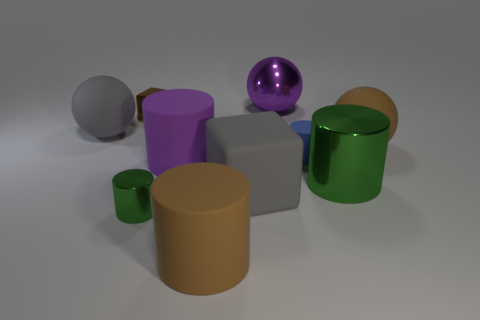Subtract 1 cylinders. How many cylinders are left? 4 Subtract all brown cylinders. How many cylinders are left? 4 Subtract all blue matte cylinders. How many cylinders are left? 4 Subtract all purple cylinders. Subtract all yellow balls. How many cylinders are left? 4 Subtract all cubes. How many objects are left? 8 Add 8 big purple matte cylinders. How many big purple matte cylinders are left? 9 Add 5 large green metallic cylinders. How many large green metallic cylinders exist? 6 Subtract 0 purple cubes. How many objects are left? 10 Subtract all small metallic spheres. Subtract all tiny brown things. How many objects are left? 9 